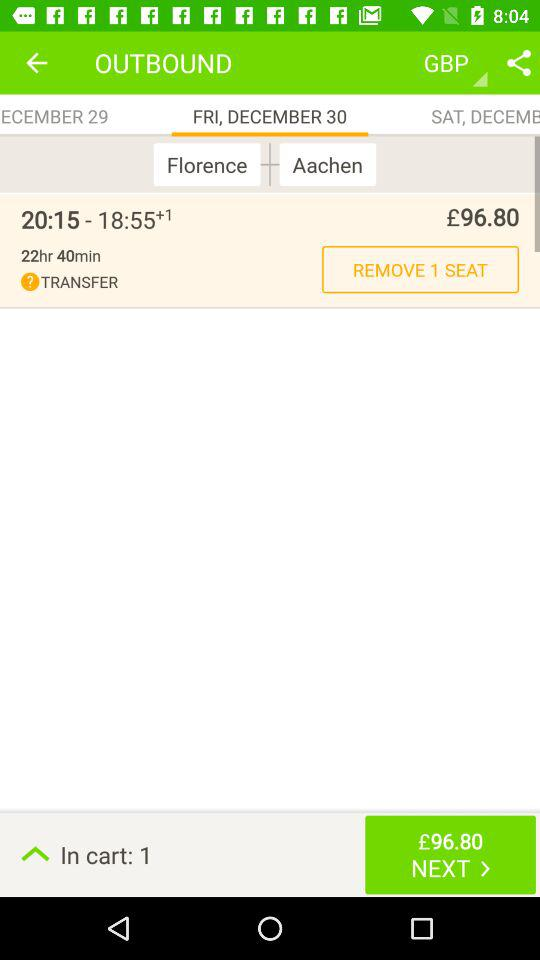What is the departure location? The departure location is Florence. 